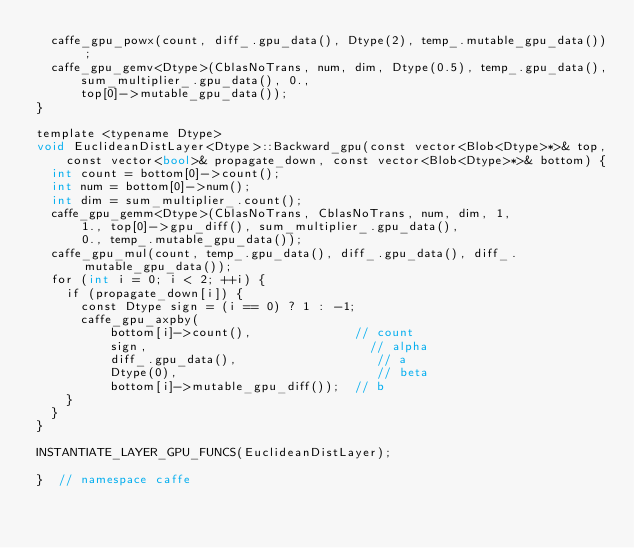<code> <loc_0><loc_0><loc_500><loc_500><_Cuda_>  caffe_gpu_powx(count, diff_.gpu_data(), Dtype(2), temp_.mutable_gpu_data());
  caffe_gpu_gemv<Dtype>(CblasNoTrans, num, dim, Dtype(0.5), temp_.gpu_data(),
      sum_multiplier_.gpu_data(), 0.,
      top[0]->mutable_gpu_data());
}

template <typename Dtype>
void EuclideanDistLayer<Dtype>::Backward_gpu(const vector<Blob<Dtype>*>& top,
    const vector<bool>& propagate_down, const vector<Blob<Dtype>*>& bottom) {
  int count = bottom[0]->count();
  int num = bottom[0]->num();
  int dim = sum_multiplier_.count();
  caffe_gpu_gemm<Dtype>(CblasNoTrans, CblasNoTrans, num, dim, 1,
      1., top[0]->gpu_diff(), sum_multiplier_.gpu_data(),
      0., temp_.mutable_gpu_data());
  caffe_gpu_mul(count, temp_.gpu_data(), diff_.gpu_data(), diff_.mutable_gpu_data());
  for (int i = 0; i < 2; ++i) {
    if (propagate_down[i]) {
      const Dtype sign = (i == 0) ? 1 : -1;
      caffe_gpu_axpby(
          bottom[i]->count(),              // count
          sign,                              // alpha
          diff_.gpu_data(),                   // a
          Dtype(0),                           // beta
          bottom[i]->mutable_gpu_diff());  // b
    }
  }
}

INSTANTIATE_LAYER_GPU_FUNCS(EuclideanDistLayer);

}  // namespace caffe
</code> 